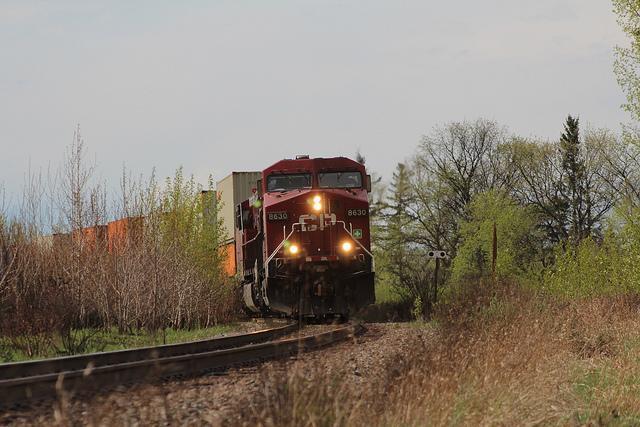How many lights are on the front of the train?
Give a very brief answer. 4. 